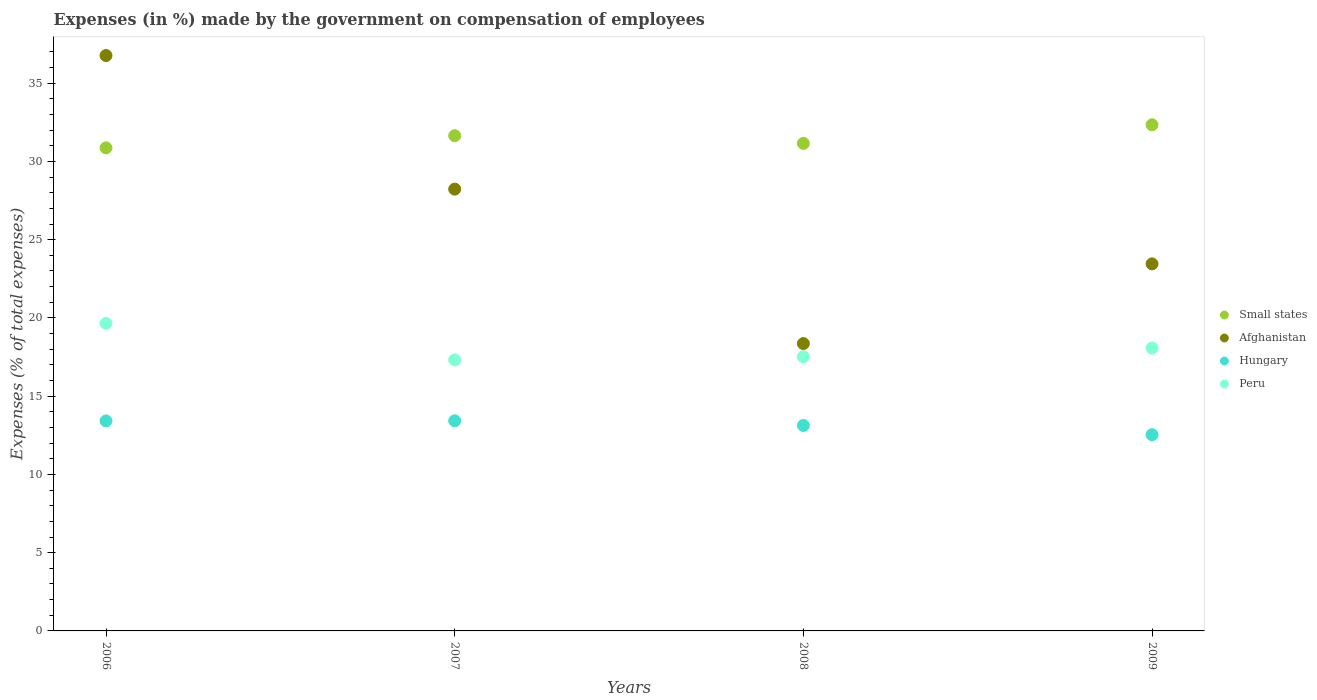How many different coloured dotlines are there?
Your answer should be compact. 4. Is the number of dotlines equal to the number of legend labels?
Offer a very short reply. Yes. What is the percentage of expenses made by the government on compensation of employees in Small states in 2008?
Your answer should be compact. 31.15. Across all years, what is the maximum percentage of expenses made by the government on compensation of employees in Peru?
Your response must be concise. 19.65. Across all years, what is the minimum percentage of expenses made by the government on compensation of employees in Peru?
Keep it short and to the point. 17.32. In which year was the percentage of expenses made by the government on compensation of employees in Afghanistan maximum?
Your answer should be compact. 2006. What is the total percentage of expenses made by the government on compensation of employees in Hungary in the graph?
Offer a very short reply. 52.51. What is the difference between the percentage of expenses made by the government on compensation of employees in Afghanistan in 2006 and that in 2009?
Your response must be concise. 13.31. What is the difference between the percentage of expenses made by the government on compensation of employees in Small states in 2006 and the percentage of expenses made by the government on compensation of employees in Peru in 2008?
Ensure brevity in your answer.  13.35. What is the average percentage of expenses made by the government on compensation of employees in Peru per year?
Your answer should be compact. 18.14. In the year 2008, what is the difference between the percentage of expenses made by the government on compensation of employees in Small states and percentage of expenses made by the government on compensation of employees in Hungary?
Your answer should be very brief. 18.02. What is the ratio of the percentage of expenses made by the government on compensation of employees in Afghanistan in 2007 to that in 2008?
Make the answer very short. 1.54. Is the difference between the percentage of expenses made by the government on compensation of employees in Small states in 2006 and 2007 greater than the difference between the percentage of expenses made by the government on compensation of employees in Hungary in 2006 and 2007?
Your answer should be compact. No. What is the difference between the highest and the second highest percentage of expenses made by the government on compensation of employees in Afghanistan?
Provide a short and direct response. 8.54. What is the difference between the highest and the lowest percentage of expenses made by the government on compensation of employees in Afghanistan?
Your response must be concise. 18.4. In how many years, is the percentage of expenses made by the government on compensation of employees in Hungary greater than the average percentage of expenses made by the government on compensation of employees in Hungary taken over all years?
Provide a short and direct response. 3. Is the sum of the percentage of expenses made by the government on compensation of employees in Peru in 2006 and 2009 greater than the maximum percentage of expenses made by the government on compensation of employees in Small states across all years?
Your answer should be very brief. Yes. Is it the case that in every year, the sum of the percentage of expenses made by the government on compensation of employees in Hungary and percentage of expenses made by the government on compensation of employees in Small states  is greater than the sum of percentage of expenses made by the government on compensation of employees in Peru and percentage of expenses made by the government on compensation of employees in Afghanistan?
Your answer should be very brief. Yes. Does the percentage of expenses made by the government on compensation of employees in Small states monotonically increase over the years?
Your response must be concise. No. How many dotlines are there?
Give a very brief answer. 4. Does the graph contain any zero values?
Your answer should be compact. No. Where does the legend appear in the graph?
Your answer should be very brief. Center right. How many legend labels are there?
Offer a very short reply. 4. How are the legend labels stacked?
Make the answer very short. Vertical. What is the title of the graph?
Provide a succinct answer. Expenses (in %) made by the government on compensation of employees. What is the label or title of the X-axis?
Offer a terse response. Years. What is the label or title of the Y-axis?
Offer a terse response. Expenses (% of total expenses). What is the Expenses (% of total expenses) in Small states in 2006?
Offer a very short reply. 30.87. What is the Expenses (% of total expenses) in Afghanistan in 2006?
Your response must be concise. 36.76. What is the Expenses (% of total expenses) of Hungary in 2006?
Keep it short and to the point. 13.42. What is the Expenses (% of total expenses) in Peru in 2006?
Keep it short and to the point. 19.65. What is the Expenses (% of total expenses) of Small states in 2007?
Provide a short and direct response. 31.64. What is the Expenses (% of total expenses) of Afghanistan in 2007?
Ensure brevity in your answer.  28.23. What is the Expenses (% of total expenses) in Hungary in 2007?
Make the answer very short. 13.43. What is the Expenses (% of total expenses) in Peru in 2007?
Give a very brief answer. 17.32. What is the Expenses (% of total expenses) in Small states in 2008?
Give a very brief answer. 31.15. What is the Expenses (% of total expenses) of Afghanistan in 2008?
Ensure brevity in your answer.  18.36. What is the Expenses (% of total expenses) in Hungary in 2008?
Make the answer very short. 13.13. What is the Expenses (% of total expenses) in Peru in 2008?
Your answer should be compact. 17.52. What is the Expenses (% of total expenses) in Small states in 2009?
Your answer should be compact. 32.34. What is the Expenses (% of total expenses) in Afghanistan in 2009?
Give a very brief answer. 23.45. What is the Expenses (% of total expenses) in Hungary in 2009?
Provide a succinct answer. 12.54. What is the Expenses (% of total expenses) in Peru in 2009?
Your response must be concise. 18.08. Across all years, what is the maximum Expenses (% of total expenses) in Small states?
Offer a very short reply. 32.34. Across all years, what is the maximum Expenses (% of total expenses) in Afghanistan?
Keep it short and to the point. 36.76. Across all years, what is the maximum Expenses (% of total expenses) of Hungary?
Your response must be concise. 13.43. Across all years, what is the maximum Expenses (% of total expenses) in Peru?
Offer a very short reply. 19.65. Across all years, what is the minimum Expenses (% of total expenses) in Small states?
Offer a very short reply. 30.87. Across all years, what is the minimum Expenses (% of total expenses) of Afghanistan?
Offer a very short reply. 18.36. Across all years, what is the minimum Expenses (% of total expenses) in Hungary?
Offer a very short reply. 12.54. Across all years, what is the minimum Expenses (% of total expenses) of Peru?
Offer a terse response. 17.32. What is the total Expenses (% of total expenses) of Small states in the graph?
Ensure brevity in your answer.  125.99. What is the total Expenses (% of total expenses) in Afghanistan in the graph?
Your answer should be very brief. 106.81. What is the total Expenses (% of total expenses) of Hungary in the graph?
Your response must be concise. 52.51. What is the total Expenses (% of total expenses) in Peru in the graph?
Give a very brief answer. 72.57. What is the difference between the Expenses (% of total expenses) in Small states in 2006 and that in 2007?
Your response must be concise. -0.78. What is the difference between the Expenses (% of total expenses) in Afghanistan in 2006 and that in 2007?
Ensure brevity in your answer.  8.54. What is the difference between the Expenses (% of total expenses) in Hungary in 2006 and that in 2007?
Your answer should be compact. -0.01. What is the difference between the Expenses (% of total expenses) of Peru in 2006 and that in 2007?
Provide a succinct answer. 2.34. What is the difference between the Expenses (% of total expenses) in Small states in 2006 and that in 2008?
Make the answer very short. -0.28. What is the difference between the Expenses (% of total expenses) in Afghanistan in 2006 and that in 2008?
Your response must be concise. 18.4. What is the difference between the Expenses (% of total expenses) of Hungary in 2006 and that in 2008?
Offer a very short reply. 0.29. What is the difference between the Expenses (% of total expenses) in Peru in 2006 and that in 2008?
Your response must be concise. 2.14. What is the difference between the Expenses (% of total expenses) in Small states in 2006 and that in 2009?
Give a very brief answer. -1.47. What is the difference between the Expenses (% of total expenses) of Afghanistan in 2006 and that in 2009?
Offer a terse response. 13.31. What is the difference between the Expenses (% of total expenses) in Hungary in 2006 and that in 2009?
Offer a very short reply. 0.88. What is the difference between the Expenses (% of total expenses) of Peru in 2006 and that in 2009?
Offer a terse response. 1.58. What is the difference between the Expenses (% of total expenses) of Small states in 2007 and that in 2008?
Provide a short and direct response. 0.49. What is the difference between the Expenses (% of total expenses) in Afghanistan in 2007 and that in 2008?
Give a very brief answer. 9.87. What is the difference between the Expenses (% of total expenses) of Hungary in 2007 and that in 2008?
Your answer should be very brief. 0.3. What is the difference between the Expenses (% of total expenses) of Small states in 2007 and that in 2009?
Offer a terse response. -0.7. What is the difference between the Expenses (% of total expenses) in Afghanistan in 2007 and that in 2009?
Make the answer very short. 4.77. What is the difference between the Expenses (% of total expenses) in Hungary in 2007 and that in 2009?
Your response must be concise. 0.89. What is the difference between the Expenses (% of total expenses) in Peru in 2007 and that in 2009?
Keep it short and to the point. -0.76. What is the difference between the Expenses (% of total expenses) of Small states in 2008 and that in 2009?
Your answer should be compact. -1.19. What is the difference between the Expenses (% of total expenses) of Afghanistan in 2008 and that in 2009?
Ensure brevity in your answer.  -5.09. What is the difference between the Expenses (% of total expenses) in Hungary in 2008 and that in 2009?
Ensure brevity in your answer.  0.59. What is the difference between the Expenses (% of total expenses) of Peru in 2008 and that in 2009?
Your answer should be very brief. -0.56. What is the difference between the Expenses (% of total expenses) of Small states in 2006 and the Expenses (% of total expenses) of Afghanistan in 2007?
Offer a terse response. 2.64. What is the difference between the Expenses (% of total expenses) in Small states in 2006 and the Expenses (% of total expenses) in Hungary in 2007?
Your answer should be compact. 17.44. What is the difference between the Expenses (% of total expenses) in Small states in 2006 and the Expenses (% of total expenses) in Peru in 2007?
Provide a short and direct response. 13.55. What is the difference between the Expenses (% of total expenses) of Afghanistan in 2006 and the Expenses (% of total expenses) of Hungary in 2007?
Make the answer very short. 23.34. What is the difference between the Expenses (% of total expenses) of Afghanistan in 2006 and the Expenses (% of total expenses) of Peru in 2007?
Make the answer very short. 19.45. What is the difference between the Expenses (% of total expenses) of Hungary in 2006 and the Expenses (% of total expenses) of Peru in 2007?
Your response must be concise. -3.9. What is the difference between the Expenses (% of total expenses) in Small states in 2006 and the Expenses (% of total expenses) in Afghanistan in 2008?
Make the answer very short. 12.5. What is the difference between the Expenses (% of total expenses) of Small states in 2006 and the Expenses (% of total expenses) of Hungary in 2008?
Ensure brevity in your answer.  17.74. What is the difference between the Expenses (% of total expenses) in Small states in 2006 and the Expenses (% of total expenses) in Peru in 2008?
Your answer should be very brief. 13.35. What is the difference between the Expenses (% of total expenses) of Afghanistan in 2006 and the Expenses (% of total expenses) of Hungary in 2008?
Your answer should be compact. 23.63. What is the difference between the Expenses (% of total expenses) of Afghanistan in 2006 and the Expenses (% of total expenses) of Peru in 2008?
Your response must be concise. 19.25. What is the difference between the Expenses (% of total expenses) in Hungary in 2006 and the Expenses (% of total expenses) in Peru in 2008?
Your response must be concise. -4.1. What is the difference between the Expenses (% of total expenses) of Small states in 2006 and the Expenses (% of total expenses) of Afghanistan in 2009?
Your answer should be very brief. 7.41. What is the difference between the Expenses (% of total expenses) of Small states in 2006 and the Expenses (% of total expenses) of Hungary in 2009?
Give a very brief answer. 18.33. What is the difference between the Expenses (% of total expenses) in Small states in 2006 and the Expenses (% of total expenses) in Peru in 2009?
Provide a succinct answer. 12.79. What is the difference between the Expenses (% of total expenses) of Afghanistan in 2006 and the Expenses (% of total expenses) of Hungary in 2009?
Offer a very short reply. 24.23. What is the difference between the Expenses (% of total expenses) in Afghanistan in 2006 and the Expenses (% of total expenses) in Peru in 2009?
Ensure brevity in your answer.  18.69. What is the difference between the Expenses (% of total expenses) of Hungary in 2006 and the Expenses (% of total expenses) of Peru in 2009?
Offer a terse response. -4.66. What is the difference between the Expenses (% of total expenses) in Small states in 2007 and the Expenses (% of total expenses) in Afghanistan in 2008?
Offer a very short reply. 13.28. What is the difference between the Expenses (% of total expenses) of Small states in 2007 and the Expenses (% of total expenses) of Hungary in 2008?
Offer a very short reply. 18.51. What is the difference between the Expenses (% of total expenses) of Small states in 2007 and the Expenses (% of total expenses) of Peru in 2008?
Your answer should be very brief. 14.12. What is the difference between the Expenses (% of total expenses) in Afghanistan in 2007 and the Expenses (% of total expenses) in Hungary in 2008?
Offer a terse response. 15.1. What is the difference between the Expenses (% of total expenses) in Afghanistan in 2007 and the Expenses (% of total expenses) in Peru in 2008?
Your answer should be very brief. 10.71. What is the difference between the Expenses (% of total expenses) of Hungary in 2007 and the Expenses (% of total expenses) of Peru in 2008?
Your answer should be very brief. -4.09. What is the difference between the Expenses (% of total expenses) in Small states in 2007 and the Expenses (% of total expenses) in Afghanistan in 2009?
Ensure brevity in your answer.  8.19. What is the difference between the Expenses (% of total expenses) of Small states in 2007 and the Expenses (% of total expenses) of Hungary in 2009?
Your answer should be compact. 19.1. What is the difference between the Expenses (% of total expenses) in Small states in 2007 and the Expenses (% of total expenses) in Peru in 2009?
Provide a succinct answer. 13.57. What is the difference between the Expenses (% of total expenses) in Afghanistan in 2007 and the Expenses (% of total expenses) in Hungary in 2009?
Provide a short and direct response. 15.69. What is the difference between the Expenses (% of total expenses) in Afghanistan in 2007 and the Expenses (% of total expenses) in Peru in 2009?
Provide a succinct answer. 10.15. What is the difference between the Expenses (% of total expenses) of Hungary in 2007 and the Expenses (% of total expenses) of Peru in 2009?
Ensure brevity in your answer.  -4.65. What is the difference between the Expenses (% of total expenses) in Small states in 2008 and the Expenses (% of total expenses) in Afghanistan in 2009?
Your response must be concise. 7.7. What is the difference between the Expenses (% of total expenses) of Small states in 2008 and the Expenses (% of total expenses) of Hungary in 2009?
Keep it short and to the point. 18.61. What is the difference between the Expenses (% of total expenses) in Small states in 2008 and the Expenses (% of total expenses) in Peru in 2009?
Your answer should be very brief. 13.07. What is the difference between the Expenses (% of total expenses) of Afghanistan in 2008 and the Expenses (% of total expenses) of Hungary in 2009?
Offer a terse response. 5.82. What is the difference between the Expenses (% of total expenses) in Afghanistan in 2008 and the Expenses (% of total expenses) in Peru in 2009?
Your answer should be compact. 0.28. What is the difference between the Expenses (% of total expenses) in Hungary in 2008 and the Expenses (% of total expenses) in Peru in 2009?
Your answer should be very brief. -4.95. What is the average Expenses (% of total expenses) of Small states per year?
Keep it short and to the point. 31.5. What is the average Expenses (% of total expenses) of Afghanistan per year?
Provide a succinct answer. 26.7. What is the average Expenses (% of total expenses) in Hungary per year?
Your answer should be compact. 13.13. What is the average Expenses (% of total expenses) in Peru per year?
Your answer should be very brief. 18.14. In the year 2006, what is the difference between the Expenses (% of total expenses) of Small states and Expenses (% of total expenses) of Afghanistan?
Offer a very short reply. -5.9. In the year 2006, what is the difference between the Expenses (% of total expenses) of Small states and Expenses (% of total expenses) of Hungary?
Provide a succinct answer. 17.45. In the year 2006, what is the difference between the Expenses (% of total expenses) of Small states and Expenses (% of total expenses) of Peru?
Offer a very short reply. 11.21. In the year 2006, what is the difference between the Expenses (% of total expenses) in Afghanistan and Expenses (% of total expenses) in Hungary?
Offer a very short reply. 23.35. In the year 2006, what is the difference between the Expenses (% of total expenses) in Afghanistan and Expenses (% of total expenses) in Peru?
Offer a very short reply. 17.11. In the year 2006, what is the difference between the Expenses (% of total expenses) in Hungary and Expenses (% of total expenses) in Peru?
Ensure brevity in your answer.  -6.24. In the year 2007, what is the difference between the Expenses (% of total expenses) of Small states and Expenses (% of total expenses) of Afghanistan?
Ensure brevity in your answer.  3.41. In the year 2007, what is the difference between the Expenses (% of total expenses) of Small states and Expenses (% of total expenses) of Hungary?
Give a very brief answer. 18.22. In the year 2007, what is the difference between the Expenses (% of total expenses) in Small states and Expenses (% of total expenses) in Peru?
Ensure brevity in your answer.  14.32. In the year 2007, what is the difference between the Expenses (% of total expenses) of Afghanistan and Expenses (% of total expenses) of Hungary?
Your answer should be compact. 14.8. In the year 2007, what is the difference between the Expenses (% of total expenses) of Afghanistan and Expenses (% of total expenses) of Peru?
Your response must be concise. 10.91. In the year 2007, what is the difference between the Expenses (% of total expenses) of Hungary and Expenses (% of total expenses) of Peru?
Make the answer very short. -3.89. In the year 2008, what is the difference between the Expenses (% of total expenses) of Small states and Expenses (% of total expenses) of Afghanistan?
Offer a terse response. 12.79. In the year 2008, what is the difference between the Expenses (% of total expenses) of Small states and Expenses (% of total expenses) of Hungary?
Your answer should be very brief. 18.02. In the year 2008, what is the difference between the Expenses (% of total expenses) in Small states and Expenses (% of total expenses) in Peru?
Your answer should be compact. 13.63. In the year 2008, what is the difference between the Expenses (% of total expenses) in Afghanistan and Expenses (% of total expenses) in Hungary?
Offer a very short reply. 5.23. In the year 2008, what is the difference between the Expenses (% of total expenses) of Afghanistan and Expenses (% of total expenses) of Peru?
Offer a very short reply. 0.84. In the year 2008, what is the difference between the Expenses (% of total expenses) in Hungary and Expenses (% of total expenses) in Peru?
Give a very brief answer. -4.39. In the year 2009, what is the difference between the Expenses (% of total expenses) in Small states and Expenses (% of total expenses) in Afghanistan?
Your response must be concise. 8.89. In the year 2009, what is the difference between the Expenses (% of total expenses) in Small states and Expenses (% of total expenses) in Hungary?
Offer a terse response. 19.8. In the year 2009, what is the difference between the Expenses (% of total expenses) of Small states and Expenses (% of total expenses) of Peru?
Make the answer very short. 14.26. In the year 2009, what is the difference between the Expenses (% of total expenses) in Afghanistan and Expenses (% of total expenses) in Hungary?
Offer a very short reply. 10.92. In the year 2009, what is the difference between the Expenses (% of total expenses) in Afghanistan and Expenses (% of total expenses) in Peru?
Your response must be concise. 5.38. In the year 2009, what is the difference between the Expenses (% of total expenses) of Hungary and Expenses (% of total expenses) of Peru?
Ensure brevity in your answer.  -5.54. What is the ratio of the Expenses (% of total expenses) of Small states in 2006 to that in 2007?
Make the answer very short. 0.98. What is the ratio of the Expenses (% of total expenses) in Afghanistan in 2006 to that in 2007?
Your answer should be very brief. 1.3. What is the ratio of the Expenses (% of total expenses) of Peru in 2006 to that in 2007?
Your answer should be very brief. 1.13. What is the ratio of the Expenses (% of total expenses) in Small states in 2006 to that in 2008?
Offer a terse response. 0.99. What is the ratio of the Expenses (% of total expenses) of Afghanistan in 2006 to that in 2008?
Make the answer very short. 2. What is the ratio of the Expenses (% of total expenses) of Peru in 2006 to that in 2008?
Ensure brevity in your answer.  1.12. What is the ratio of the Expenses (% of total expenses) in Small states in 2006 to that in 2009?
Your answer should be very brief. 0.95. What is the ratio of the Expenses (% of total expenses) of Afghanistan in 2006 to that in 2009?
Offer a very short reply. 1.57. What is the ratio of the Expenses (% of total expenses) of Hungary in 2006 to that in 2009?
Ensure brevity in your answer.  1.07. What is the ratio of the Expenses (% of total expenses) in Peru in 2006 to that in 2009?
Give a very brief answer. 1.09. What is the ratio of the Expenses (% of total expenses) in Small states in 2007 to that in 2008?
Give a very brief answer. 1.02. What is the ratio of the Expenses (% of total expenses) in Afghanistan in 2007 to that in 2008?
Give a very brief answer. 1.54. What is the ratio of the Expenses (% of total expenses) in Hungary in 2007 to that in 2008?
Your response must be concise. 1.02. What is the ratio of the Expenses (% of total expenses) in Small states in 2007 to that in 2009?
Offer a very short reply. 0.98. What is the ratio of the Expenses (% of total expenses) in Afghanistan in 2007 to that in 2009?
Keep it short and to the point. 1.2. What is the ratio of the Expenses (% of total expenses) in Hungary in 2007 to that in 2009?
Offer a terse response. 1.07. What is the ratio of the Expenses (% of total expenses) of Peru in 2007 to that in 2009?
Ensure brevity in your answer.  0.96. What is the ratio of the Expenses (% of total expenses) of Small states in 2008 to that in 2009?
Keep it short and to the point. 0.96. What is the ratio of the Expenses (% of total expenses) of Afghanistan in 2008 to that in 2009?
Your answer should be very brief. 0.78. What is the ratio of the Expenses (% of total expenses) of Hungary in 2008 to that in 2009?
Offer a terse response. 1.05. What is the ratio of the Expenses (% of total expenses) in Peru in 2008 to that in 2009?
Your answer should be very brief. 0.97. What is the difference between the highest and the second highest Expenses (% of total expenses) in Small states?
Your response must be concise. 0.7. What is the difference between the highest and the second highest Expenses (% of total expenses) of Afghanistan?
Give a very brief answer. 8.54. What is the difference between the highest and the second highest Expenses (% of total expenses) in Hungary?
Make the answer very short. 0.01. What is the difference between the highest and the second highest Expenses (% of total expenses) of Peru?
Provide a short and direct response. 1.58. What is the difference between the highest and the lowest Expenses (% of total expenses) in Small states?
Provide a succinct answer. 1.47. What is the difference between the highest and the lowest Expenses (% of total expenses) in Afghanistan?
Provide a short and direct response. 18.4. What is the difference between the highest and the lowest Expenses (% of total expenses) in Hungary?
Your response must be concise. 0.89. What is the difference between the highest and the lowest Expenses (% of total expenses) of Peru?
Keep it short and to the point. 2.34. 